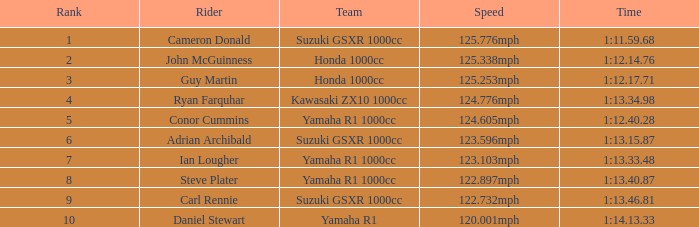What time did team kawasaki zx10 1000cc have? 1:13.34.98. 